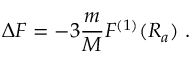Convert formula to latex. <formula><loc_0><loc_0><loc_500><loc_500>\Delta F = - 3 \frac { m } { M } F ^ { ( 1 ) } ( R _ { a } ) \ .</formula> 